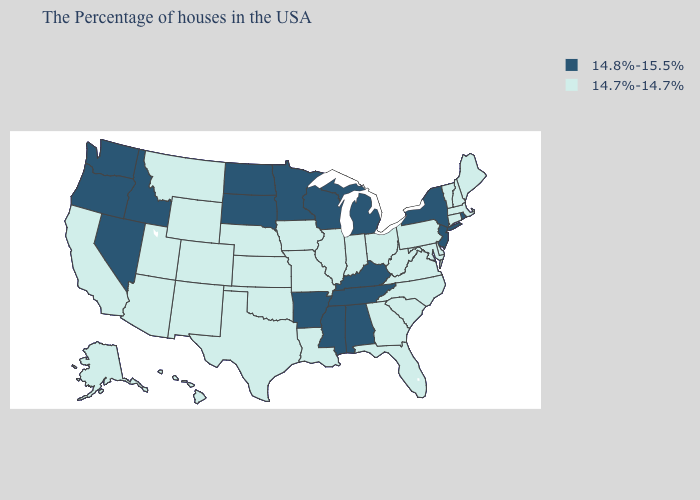Does Connecticut have the highest value in the Northeast?
Concise answer only. No. Which states have the lowest value in the USA?
Be succinct. Maine, Massachusetts, New Hampshire, Vermont, Connecticut, Delaware, Maryland, Pennsylvania, Virginia, North Carolina, South Carolina, West Virginia, Ohio, Florida, Georgia, Indiana, Illinois, Louisiana, Missouri, Iowa, Kansas, Nebraska, Oklahoma, Texas, Wyoming, Colorado, New Mexico, Utah, Montana, Arizona, California, Alaska, Hawaii. What is the value of Iowa?
Write a very short answer. 14.7%-14.7%. What is the value of Rhode Island?
Give a very brief answer. 14.8%-15.5%. What is the value of Utah?
Keep it brief. 14.7%-14.7%. Does Mississippi have the same value as Nevada?
Give a very brief answer. Yes. Does Nevada have the highest value in the West?
Give a very brief answer. Yes. Which states have the lowest value in the USA?
Quick response, please. Maine, Massachusetts, New Hampshire, Vermont, Connecticut, Delaware, Maryland, Pennsylvania, Virginia, North Carolina, South Carolina, West Virginia, Ohio, Florida, Georgia, Indiana, Illinois, Louisiana, Missouri, Iowa, Kansas, Nebraska, Oklahoma, Texas, Wyoming, Colorado, New Mexico, Utah, Montana, Arizona, California, Alaska, Hawaii. Does Iowa have the highest value in the MidWest?
Concise answer only. No. Name the states that have a value in the range 14.8%-15.5%?
Write a very short answer. Rhode Island, New York, New Jersey, Michigan, Kentucky, Alabama, Tennessee, Wisconsin, Mississippi, Arkansas, Minnesota, South Dakota, North Dakota, Idaho, Nevada, Washington, Oregon. Name the states that have a value in the range 14.8%-15.5%?
Short answer required. Rhode Island, New York, New Jersey, Michigan, Kentucky, Alabama, Tennessee, Wisconsin, Mississippi, Arkansas, Minnesota, South Dakota, North Dakota, Idaho, Nevada, Washington, Oregon. Is the legend a continuous bar?
Quick response, please. No. What is the value of New Hampshire?
Give a very brief answer. 14.7%-14.7%. Is the legend a continuous bar?
Keep it brief. No. Name the states that have a value in the range 14.7%-14.7%?
Give a very brief answer. Maine, Massachusetts, New Hampshire, Vermont, Connecticut, Delaware, Maryland, Pennsylvania, Virginia, North Carolina, South Carolina, West Virginia, Ohio, Florida, Georgia, Indiana, Illinois, Louisiana, Missouri, Iowa, Kansas, Nebraska, Oklahoma, Texas, Wyoming, Colorado, New Mexico, Utah, Montana, Arizona, California, Alaska, Hawaii. 